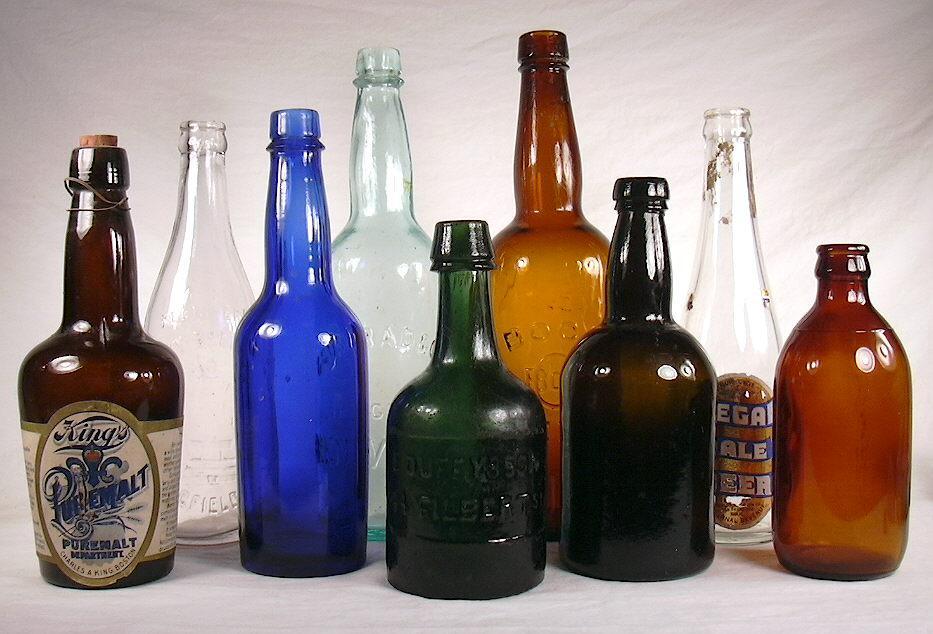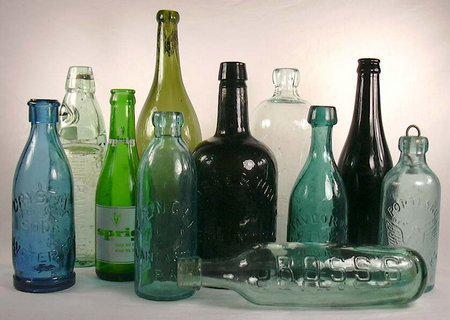The first image is the image on the left, the second image is the image on the right. Considering the images on both sides, is "One image features only upright bottles in a variety of shapes, sizes and colors, and includes at least one bottle with a paper label." valid? Answer yes or no. Yes. The first image is the image on the left, the second image is the image on the right. For the images displayed, is the sentence "There is a blue bottle in both images." factually correct? Answer yes or no. Yes. 